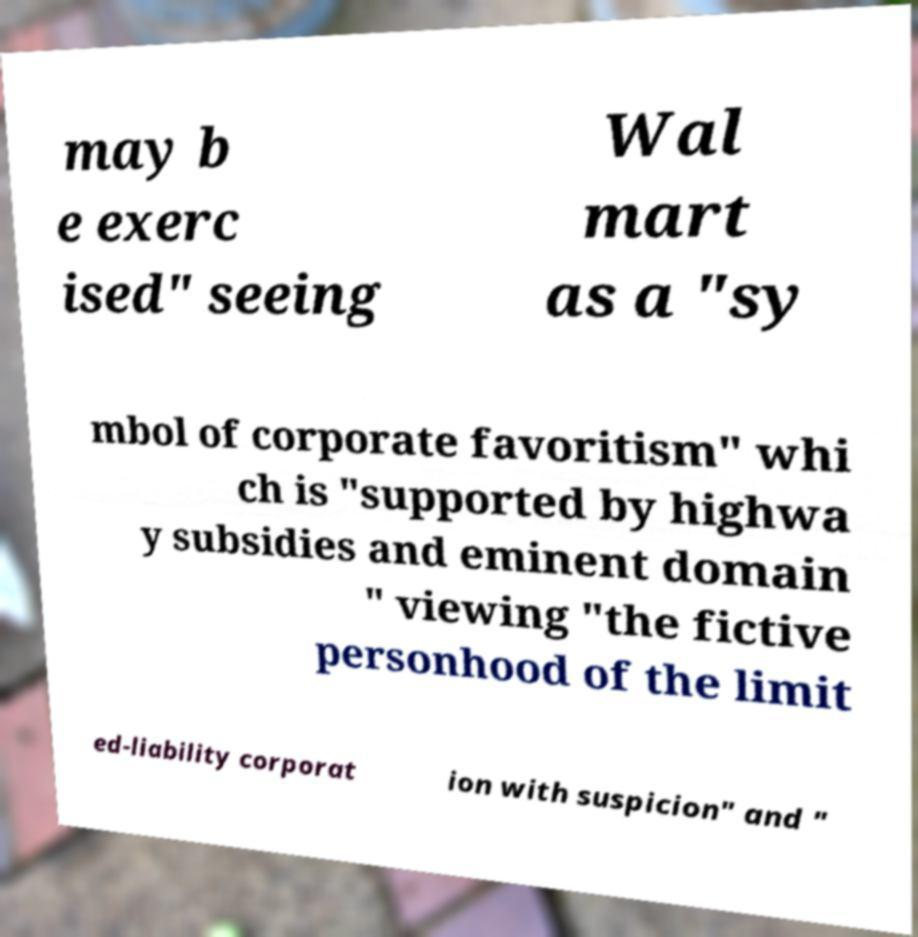Please identify and transcribe the text found in this image. may b e exerc ised" seeing Wal mart as a "sy mbol of corporate favoritism" whi ch is "supported by highwa y subsidies and eminent domain " viewing "the fictive personhood of the limit ed-liability corporat ion with suspicion" and " 